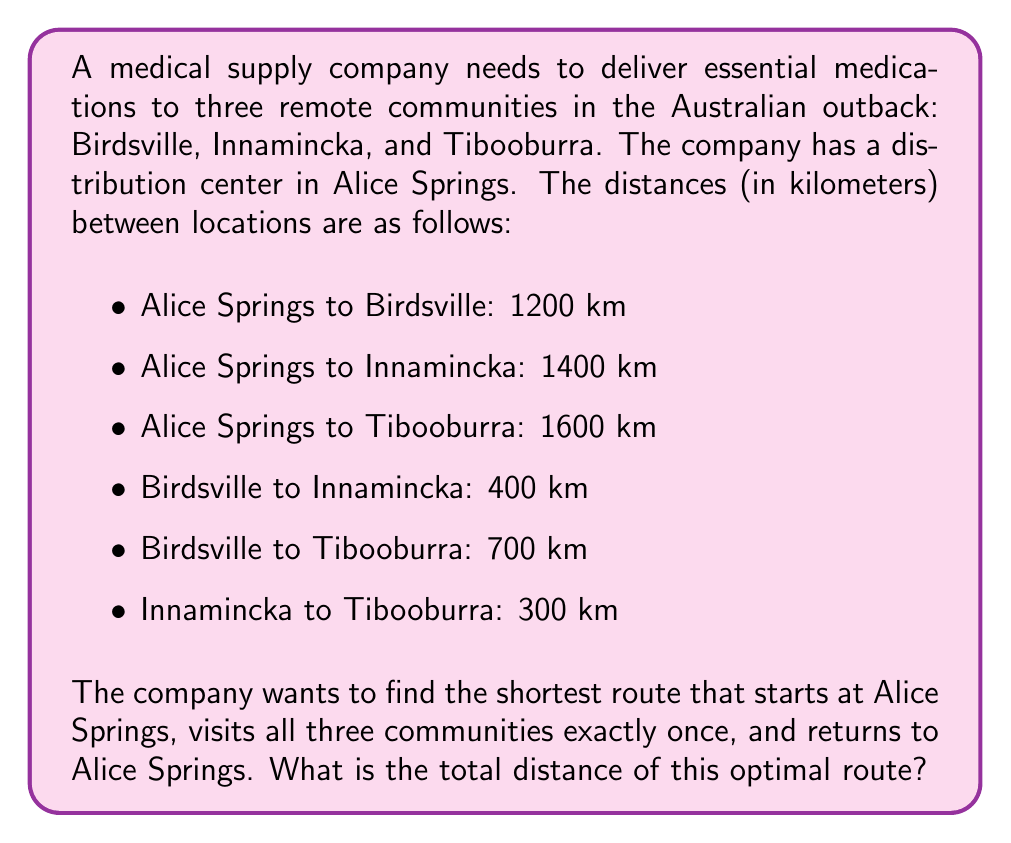Solve this math problem. To solve this problem, we need to use the concept of the Traveling Salesman Problem (TSP) in Operations Research. Since we have a small number of locations, we can solve this by evaluating all possible routes.

The possible routes are:
1. Alice Springs → Birdsville → Innamincka → Tibooburra → Alice Springs
2. Alice Springs → Birdsville → Tibooburra → Innamincka → Alice Springs
3. Alice Springs → Innamincka → Birdsville → Tibooburra → Alice Springs
4. Alice Springs → Innamincka → Tibooburra → Birdsville → Alice Springs
5. Alice Springs → Tibooburra → Birdsville → Innamincka → Alice Springs
6. Alice Springs → Tibooburra → Innamincka → Birdsville → Alice Springs

Let's calculate the total distance for each route:

1. $1200 + 400 + 300 + 1600 = 3500$ km
2. $1200 + 700 + 300 + 1400 = 3600$ km
3. $1400 + 400 + 700 + 1600 = 4100$ km
4. $1400 + 300 + 700 + 1200 = 3600$ km
5. $1600 + 700 + 400 + 1400 = 4100$ km
6. $1600 + 300 + 400 + 1200 = 3500$ km

The shortest routes are 1 and 6, both with a total distance of 3500 km.
Answer: The optimal route has a total distance of 3500 km. 